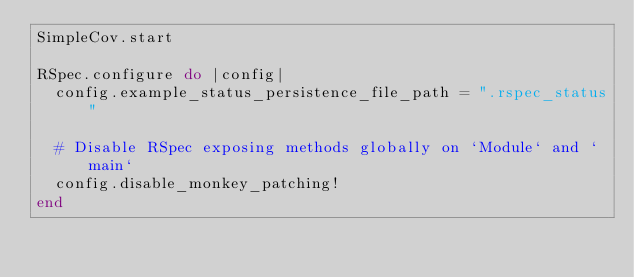<code> <loc_0><loc_0><loc_500><loc_500><_Ruby_>SimpleCov.start

RSpec.configure do |config|
  config.example_status_persistence_file_path = ".rspec_status"

  # Disable RSpec exposing methods globally on `Module` and `main`
  config.disable_monkey_patching!
end
</code> 